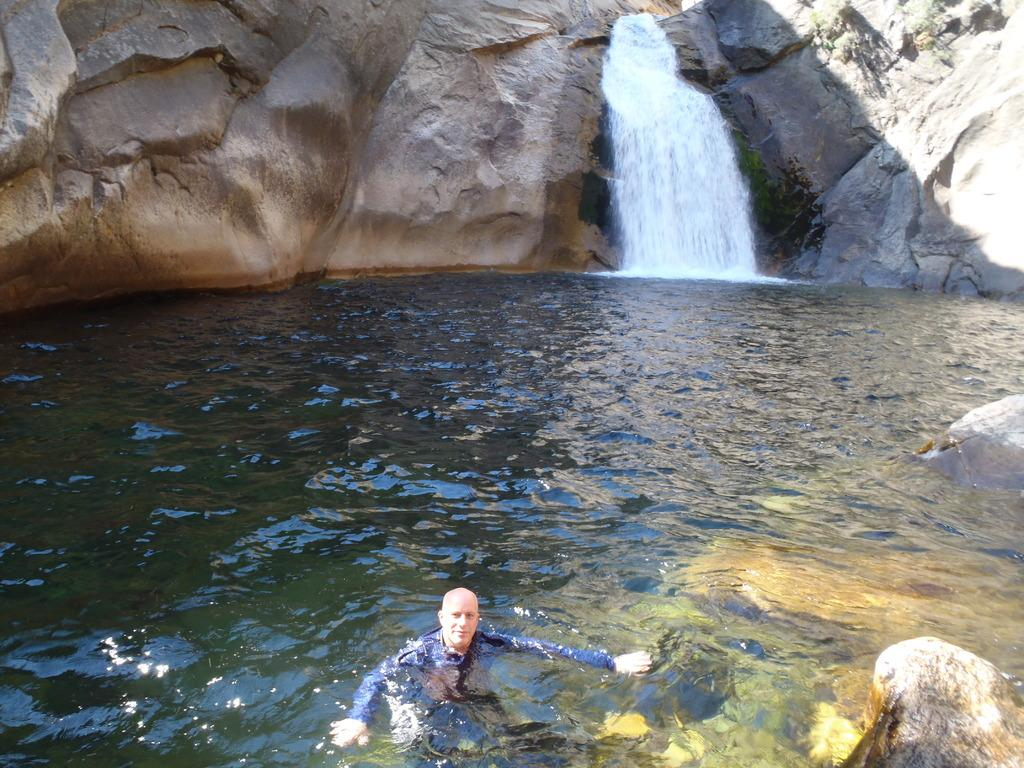What is the person in the image doing? The person is swimming in the water. What can be seen in the background of the image? There is a waterfall in the background of the image. What language is the person speaking while swimming in the image? There is no indication of the person speaking any language in the image, as it only shows them swimming. 